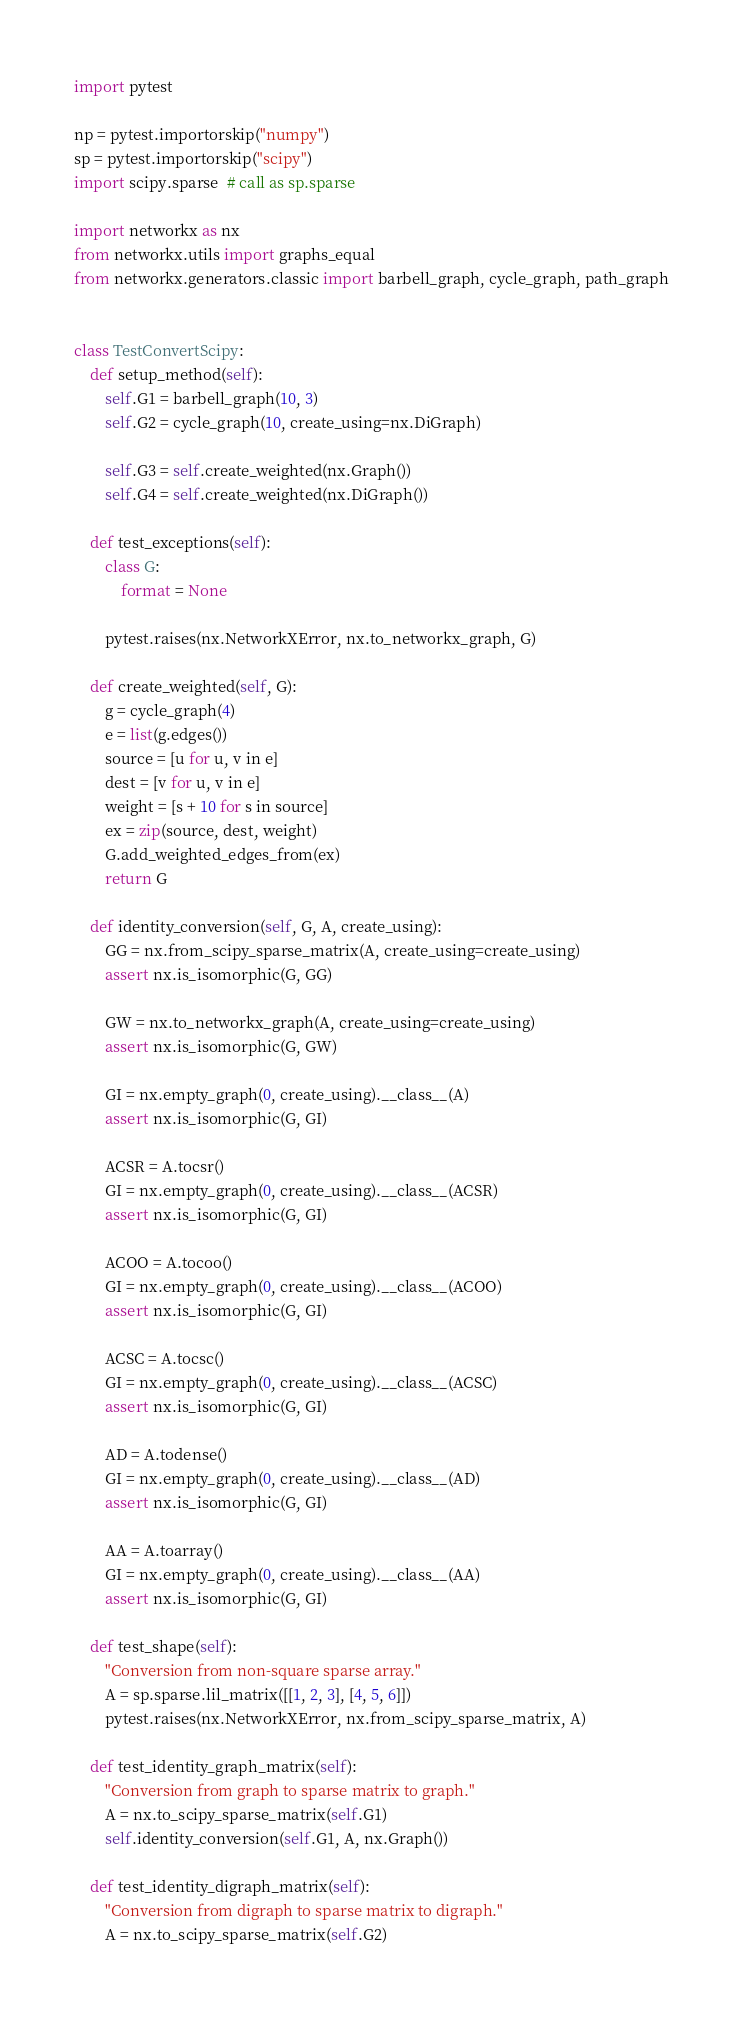<code> <loc_0><loc_0><loc_500><loc_500><_Python_>import pytest

np = pytest.importorskip("numpy")
sp = pytest.importorskip("scipy")
import scipy.sparse  # call as sp.sparse

import networkx as nx
from networkx.utils import graphs_equal
from networkx.generators.classic import barbell_graph, cycle_graph, path_graph


class TestConvertScipy:
    def setup_method(self):
        self.G1 = barbell_graph(10, 3)
        self.G2 = cycle_graph(10, create_using=nx.DiGraph)

        self.G3 = self.create_weighted(nx.Graph())
        self.G4 = self.create_weighted(nx.DiGraph())

    def test_exceptions(self):
        class G:
            format = None

        pytest.raises(nx.NetworkXError, nx.to_networkx_graph, G)

    def create_weighted(self, G):
        g = cycle_graph(4)
        e = list(g.edges())
        source = [u for u, v in e]
        dest = [v for u, v in e]
        weight = [s + 10 for s in source]
        ex = zip(source, dest, weight)
        G.add_weighted_edges_from(ex)
        return G

    def identity_conversion(self, G, A, create_using):
        GG = nx.from_scipy_sparse_matrix(A, create_using=create_using)
        assert nx.is_isomorphic(G, GG)

        GW = nx.to_networkx_graph(A, create_using=create_using)
        assert nx.is_isomorphic(G, GW)

        GI = nx.empty_graph(0, create_using).__class__(A)
        assert nx.is_isomorphic(G, GI)

        ACSR = A.tocsr()
        GI = nx.empty_graph(0, create_using).__class__(ACSR)
        assert nx.is_isomorphic(G, GI)

        ACOO = A.tocoo()
        GI = nx.empty_graph(0, create_using).__class__(ACOO)
        assert nx.is_isomorphic(G, GI)

        ACSC = A.tocsc()
        GI = nx.empty_graph(0, create_using).__class__(ACSC)
        assert nx.is_isomorphic(G, GI)

        AD = A.todense()
        GI = nx.empty_graph(0, create_using).__class__(AD)
        assert nx.is_isomorphic(G, GI)

        AA = A.toarray()
        GI = nx.empty_graph(0, create_using).__class__(AA)
        assert nx.is_isomorphic(G, GI)

    def test_shape(self):
        "Conversion from non-square sparse array."
        A = sp.sparse.lil_matrix([[1, 2, 3], [4, 5, 6]])
        pytest.raises(nx.NetworkXError, nx.from_scipy_sparse_matrix, A)

    def test_identity_graph_matrix(self):
        "Conversion from graph to sparse matrix to graph."
        A = nx.to_scipy_sparse_matrix(self.G1)
        self.identity_conversion(self.G1, A, nx.Graph())

    def test_identity_digraph_matrix(self):
        "Conversion from digraph to sparse matrix to digraph."
        A = nx.to_scipy_sparse_matrix(self.G2)</code> 